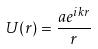Convert formula to latex. <formula><loc_0><loc_0><loc_500><loc_500>U ( r ) = \frac { a e ^ { i k r } } { r }</formula> 